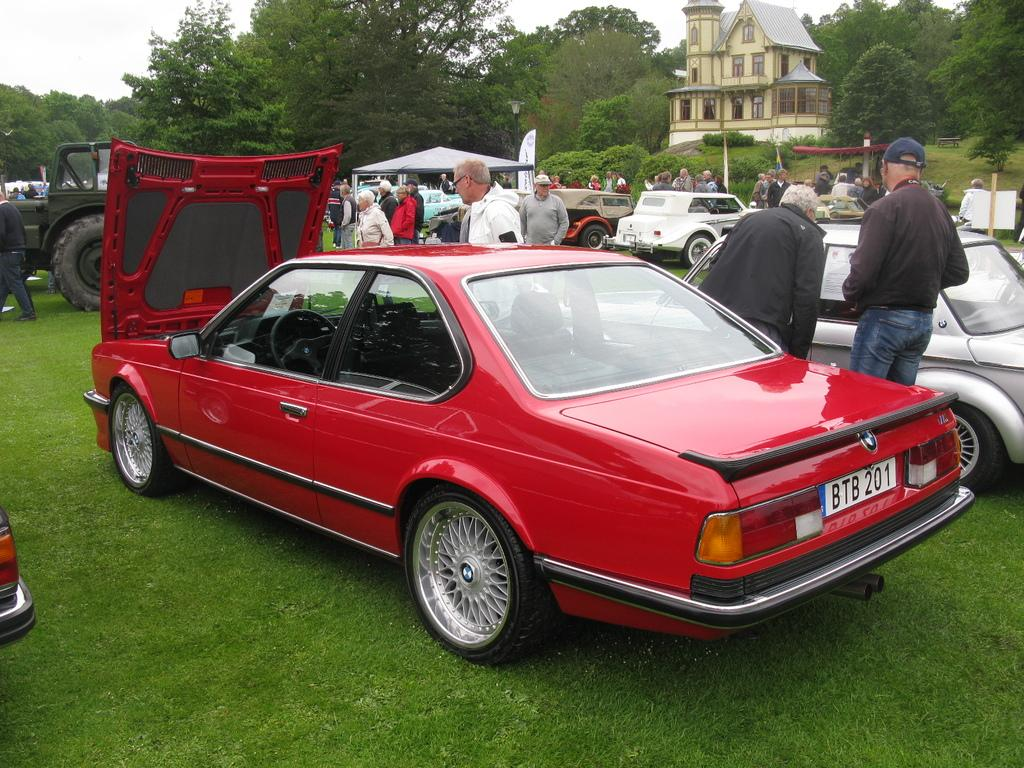What type of structure is present in the image? There is a building in the image. What natural elements can be seen in the image? There are trees and grass in the image. What temporary shelter is visible in the image? There is a tent in the image. What type of man-made object provides illumination in the image? There is a light pole in the image. What mode of transportation can be seen in the image? Vehicles are visible in the image. What human activity is depicted in the image? People are standing in the image. What part of the environment is visible in the image? The sky is visible in the image. What type of mark can be seen on the wrist of the person standing in the image? There is no information about any marks on the wrists of the people in the image. Who is driving the vehicle in the image? There is no information about anyone driving a vehicle in the image. 